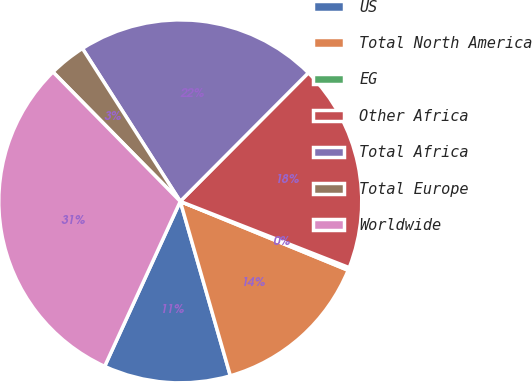Convert chart. <chart><loc_0><loc_0><loc_500><loc_500><pie_chart><fcel>US<fcel>Total North America<fcel>EG<fcel>Other Africa<fcel>Total Africa<fcel>Total Europe<fcel>Worldwide<nl><fcel>11.29%<fcel>14.35%<fcel>0.25%<fcel>18.48%<fcel>21.53%<fcel>3.31%<fcel>30.79%<nl></chart> 